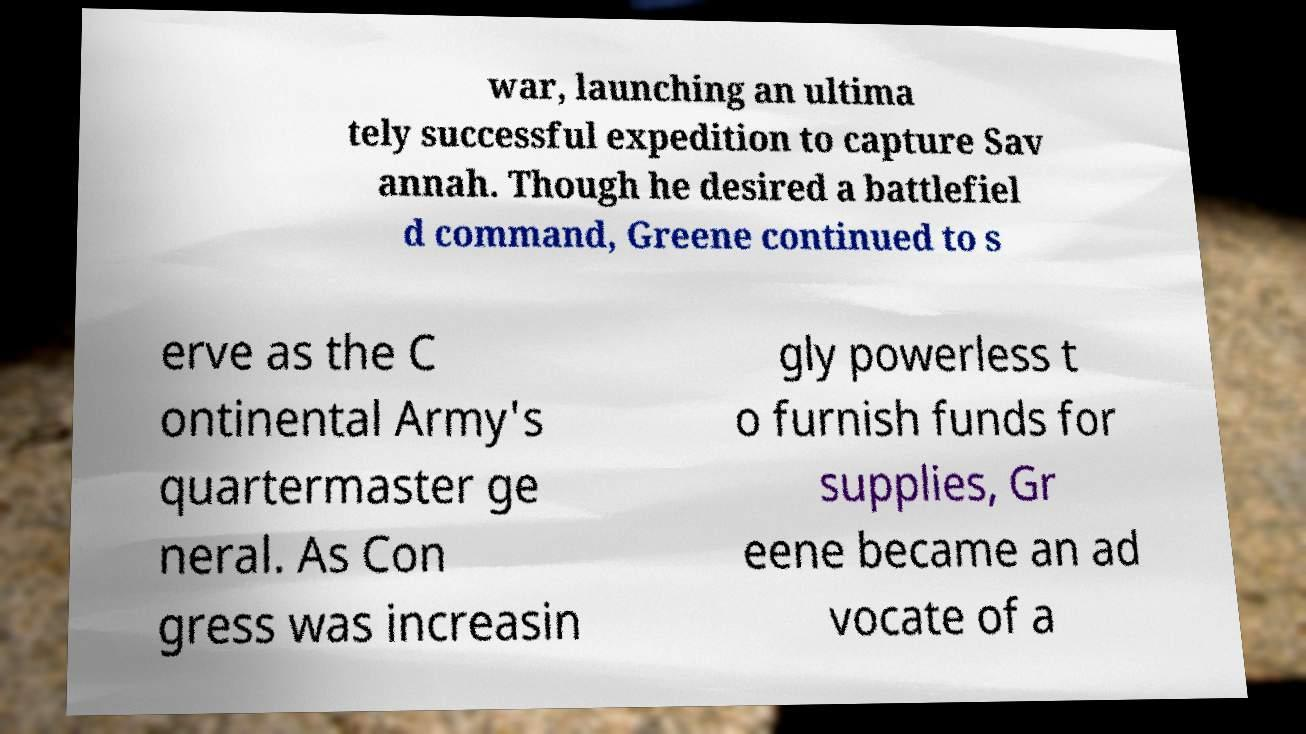Can you accurately transcribe the text from the provided image for me? war, launching an ultima tely successful expedition to capture Sav annah. Though he desired a battlefiel d command, Greene continued to s erve as the C ontinental Army's quartermaster ge neral. As Con gress was increasin gly powerless t o furnish funds for supplies, Gr eene became an ad vocate of a 